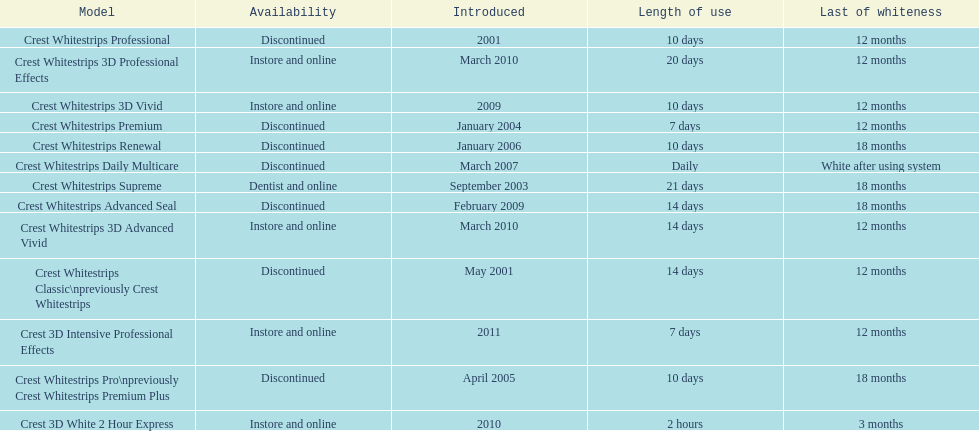How many models require less than a week of use? 2. 